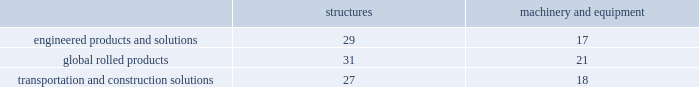Arconic and subsidiaries notes to the consolidated financial statements ( dollars in millions , except per-share amounts ) a .
Summary of significant accounting policies basis of presentation .
The consolidated financial statements of arconic inc .
And subsidiaries ( 201carconic 201d or the 201ccompany 201d ) are prepared in conformity with accounting principles generally accepted in the united states of america ( gaap ) and require management to make certain judgments , estimates , and assumptions .
These may affect the reported amounts of assets and liabilities and the disclosure of contingent assets and liabilities at the date of the financial statements .
They also may affect the reported amounts of revenues and expenses during the reporting period .
Actual results could differ from those estimates upon subsequent resolution of identified matters .
Certain amounts in previously issued financial statements were reclassified to conform to the current period presentation ( see below and note c ) on january 1 , 2018 , arconic adopted new guidance issued by the financial accounting standards board ( fasb ) related to the following : presentation of net periodic pension cost and net periodic postretirement benefit cost that required a reclassification of costs within the statement of consolidated operations ; presentation of certain cash receipts and cash payments within the statement of consolidated cash flows that required a reclassification of amounts between operating and either financing or investing activities ; the classification of restricted cash within the statement of consolidated cash flows ; and the reclassification from accumulated other comprehensive loss to accumulated deficit in the consolidated balance sheet of stranded tax effects resulting from the tax cuts and jobs act enacted on december 22 , 2017 .
See recently adopted accounting guidance below for further details .
Also on january 1 , 2018 , the company changed its primary measure of segment performance from adjusted earnings before interest , tax , depreciation and amortization ( 201cadjusted ebitda 201d ) to segment operating profit , which more closely aligns segment performance with operating income as presented in the statement of consolidated operations .
See note c for further details .
The separation of alcoa inc .
Into two standalone , publicly-traded companies , arconic inc .
( the new name for alcoa inc. ) and alcoa corporation , became effective on november 1 , 2016 ( the 201cseparation transaction 201d ) .
The financial results of alcoa corporation for 2016 have been retrospectively reflected in the statement of consolidated operations as discontinued operations and , as such , have been excluded from continuing operations and segment results for 2016 .
The cash flows and comprehensive income related to alcoa corporation have not been segregated and are included in the statement of consolidated cash flows and statement of consolidated comprehensive income ( loss ) , respectively , for 2016 .
See note v for additional information related to the separation transaction and discontinued operations .
Principles of consolidation .
The consolidated financial statements include the accounts of arconic and companies in which arconic has a controlling interest .
Intercompany transactions have been eliminated .
Investments in affiliates in which arconic cannot exercise significant influence are accounted for on the cost method .
Management also evaluates whether an arconic entity or interest is a variable interest entity and whether arconic is the primary beneficiary .
Consolidation is required if both of these criteria are met .
Arconic does not have any variable interest entities requiring consolidation .
Cash equivalents .
Cash equivalents are highly liquid investments purchased with an original maturity of three months or less .
Inventory valuation .
Inventories are carried at the lower of cost and net realizable value , with cost for approximately half of u.s .
Inventories determined under the last-in , first-out ( lifo ) method .
The cost of other inventories is determined under a combination of the first-in , first-out ( fifo ) and average-cost methods .
Properties , plants , and equipment .
Properties , plants , and equipment are recorded at cost .
Depreciation is recorded principally on the straight-line method at rates based on the estimated useful lives of the assets .
The table details the weighted-average useful lives of structures and machinery and equipment by reporting segment ( numbers in years ) : .
Gains or losses from the sale of asset groups are generally recorded in restructuring and other charges while the sale of individual assets are recorded in other expense ( income ) , net ( see policy below for assets classified as held for sale and discontinued operations ) .
Repairs and maintenance are charged to expense as incurred .
Interest related to the construction of qualifying assets is capitalized as part of the construction costs. .
What is the difference between the weighted average useful lives of structures and machinery/equipment in the engineered products and solutions segment , in years? 
Rationale: it is the difference between the number of years .
Computations: (29 - 17)
Answer: 12.0. 